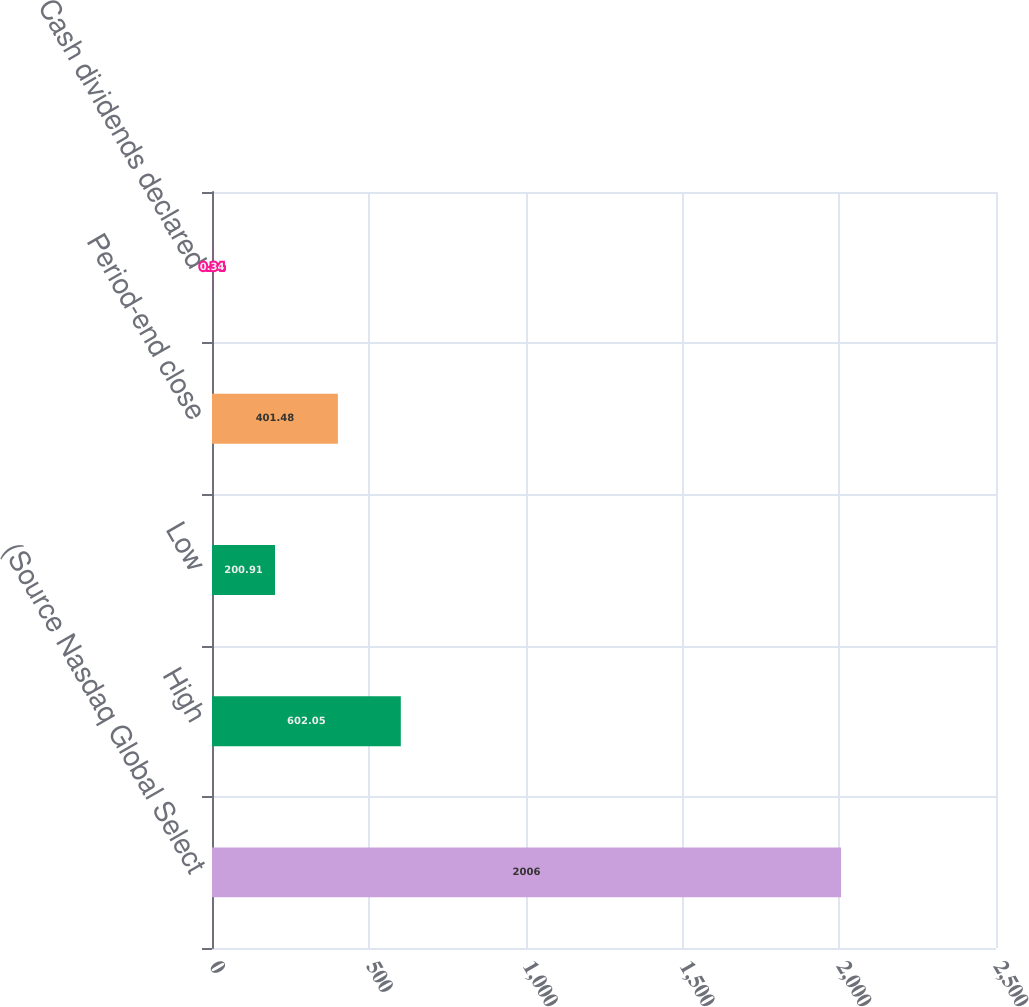<chart> <loc_0><loc_0><loc_500><loc_500><bar_chart><fcel>(Source Nasdaq Global Select<fcel>High<fcel>Low<fcel>Period-end close<fcel>Cash dividends declared<nl><fcel>2006<fcel>602.05<fcel>200.91<fcel>401.48<fcel>0.34<nl></chart> 